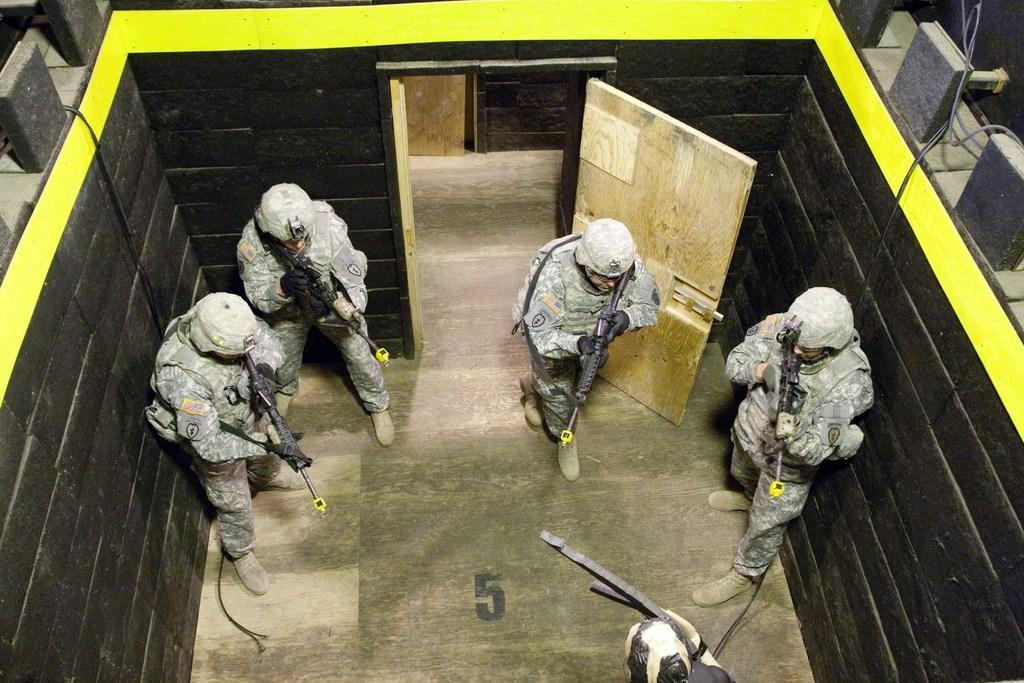How would you summarize this image in a sentence or two? In this picture four army men wearing helmet, gloves, shirt, trouser and shoes. They are holding a gun. At the bottom there is a man who is wearing black dress. At the top there is a door. 